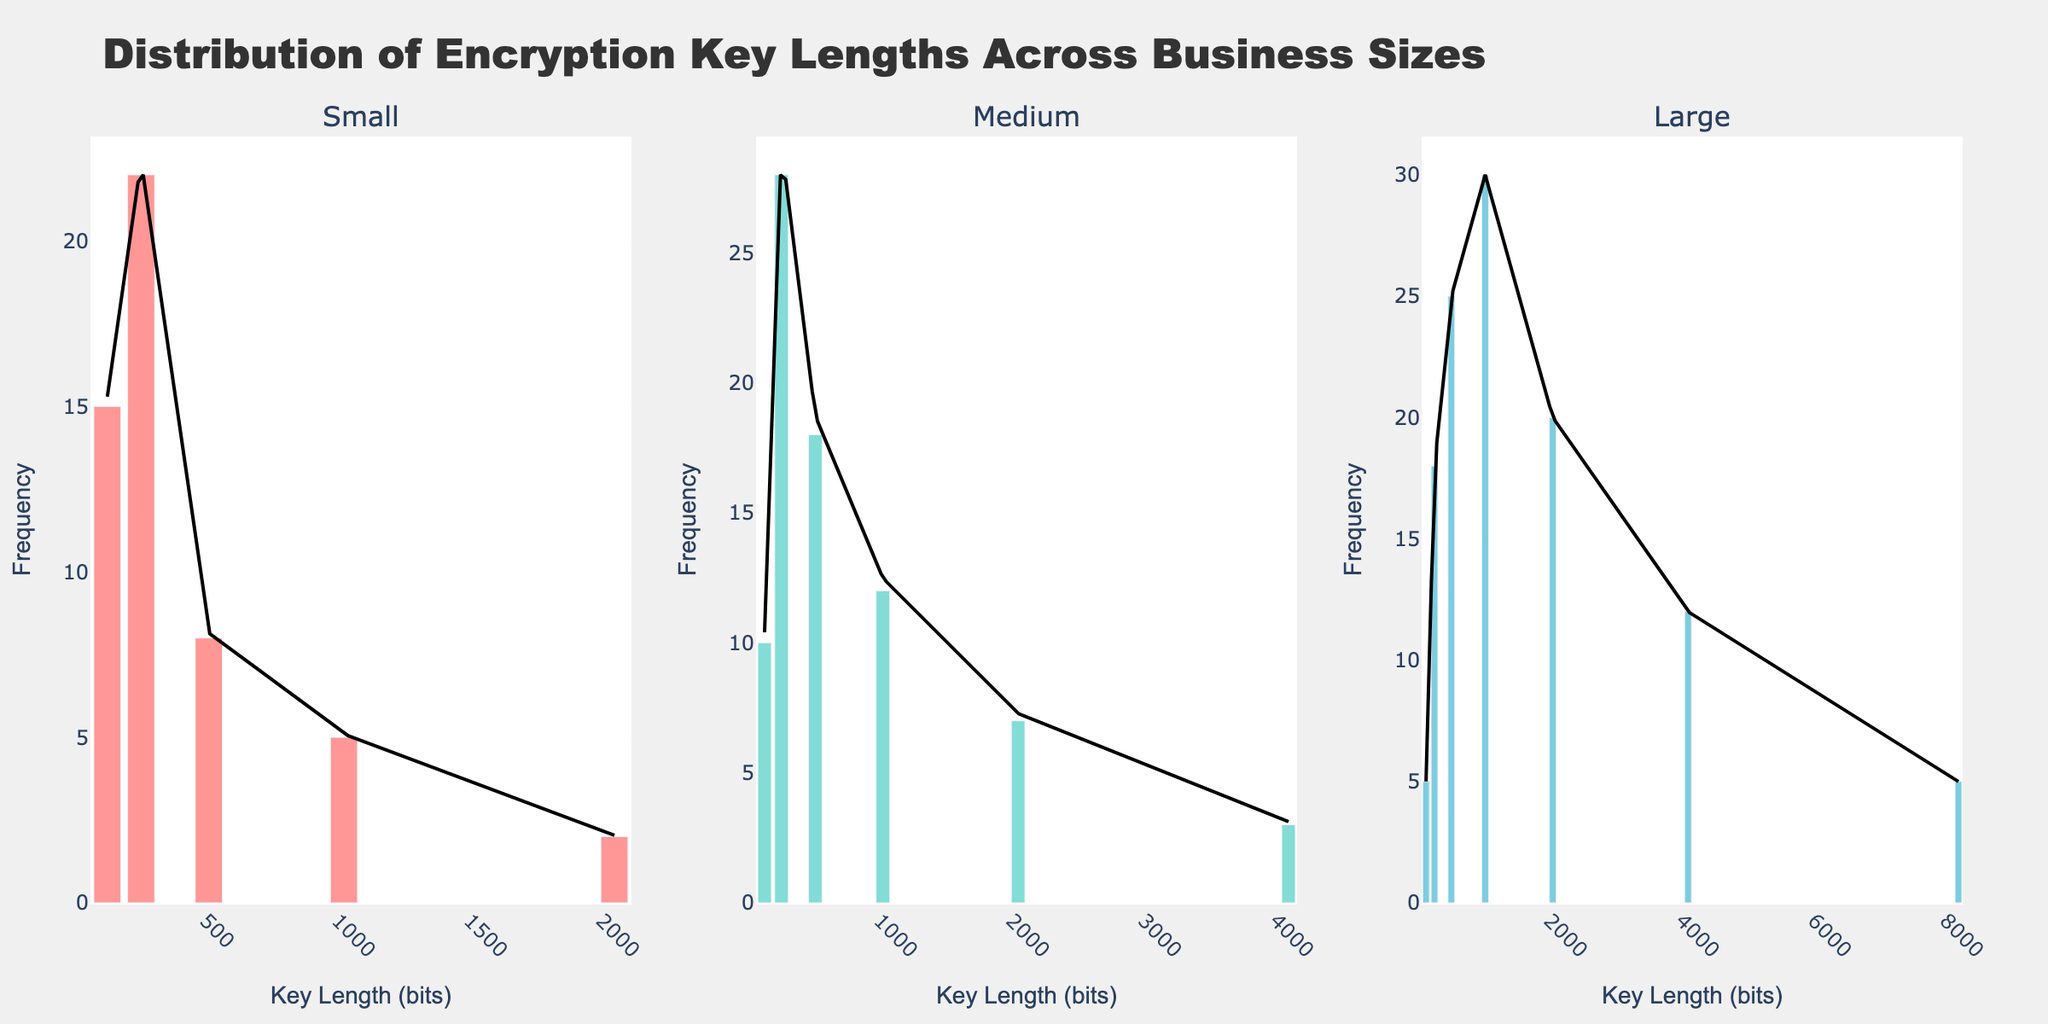What is the title of the figure? The title is typically displayed at the top of the figure. For this figure, it is "Distribution of Encryption Key Lengths Across Business Sizes."
Answer: Distribution of Encryption Key Lengths Across Business Sizes What is the range of key lengths used by small businesses? The histogram for small businesses shows bars at key lengths of 128, 256, 512, 1024, and 2048 bits.
Answer: 128 to 2048 bits Which business size uses the widest range of key lengths? By comparing the x-axis ranges in the three subplots, the large businesses have key lengths ranging from 128 to 8192 bits.
Answer: Large What is the most frequently used key length in medium businesses? In the medium business subplot, the tallest bar corresponds to the key length 256 bits.
Answer: 256 bits How does the frequency of the 2048-bit key length in large businesses compare to medium businesses? The bar for the 2048-bit key length in large businesses is taller than the corresponding bar in medium businesses. By counting, it has a frequency of 20 in large businesses and 7 in medium businesses.
Answer: Higher in large businesses What is the least frequent key length used in small businesses? In the small business subplot, the key length with the shortest bar is 2048 bits.
Answer: 2048 bits Compare the frequency of the 1024-bit key length across all business sizes. The frequencies for the 1024-bit key length are 5 in small, 12 in medium, and 30 in large businesses.
Answer: Small: 5, Medium: 12, Large: 30 What is the trend shown by the KDE curve for large businesses? The KDE curve for large businesses peaks around 1024 bits and then gradually decreases, showing higher densities at 512 and 1024 bits, and a smaller peak around 2048 bits.
Answer: Peaks at 512, 1024 and 2048 bits Is there any key length that is used by all the business sizes? The x-axis in each subplot contains the key length 128, 256, 512, and 1024 bits, indicating these key lengths are used by all business sizes.
Answer: 128, 256, 512, 1024 bits 